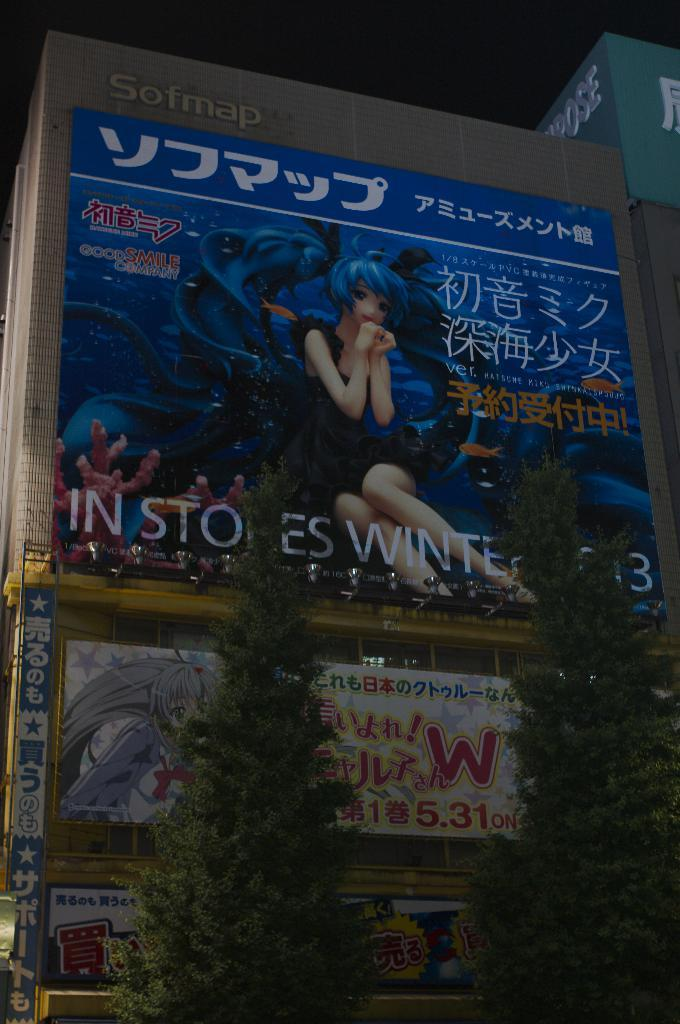Provide a one-sentence caption for the provided image. An electronic billboard shows a product which promises to be in stores by winter. 